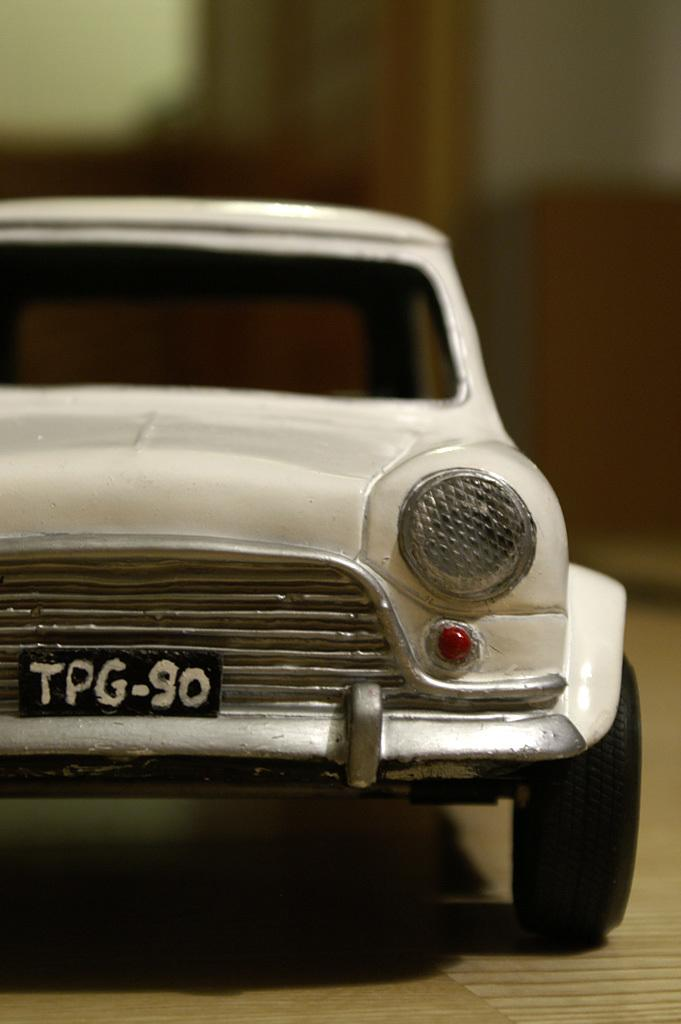What is the main subject of the picture? The main subject of the picture is a toy car. Where is the toy car located in the image? The toy car is in the middle of the image. What color is the toy car? The toy car is white in color. What type of soup is being served in the image? There is no soup present in the image; it features a white toy car in the middle. Is there a note attached to the toy car in the image? There is no note attached to the toy car in the image. 